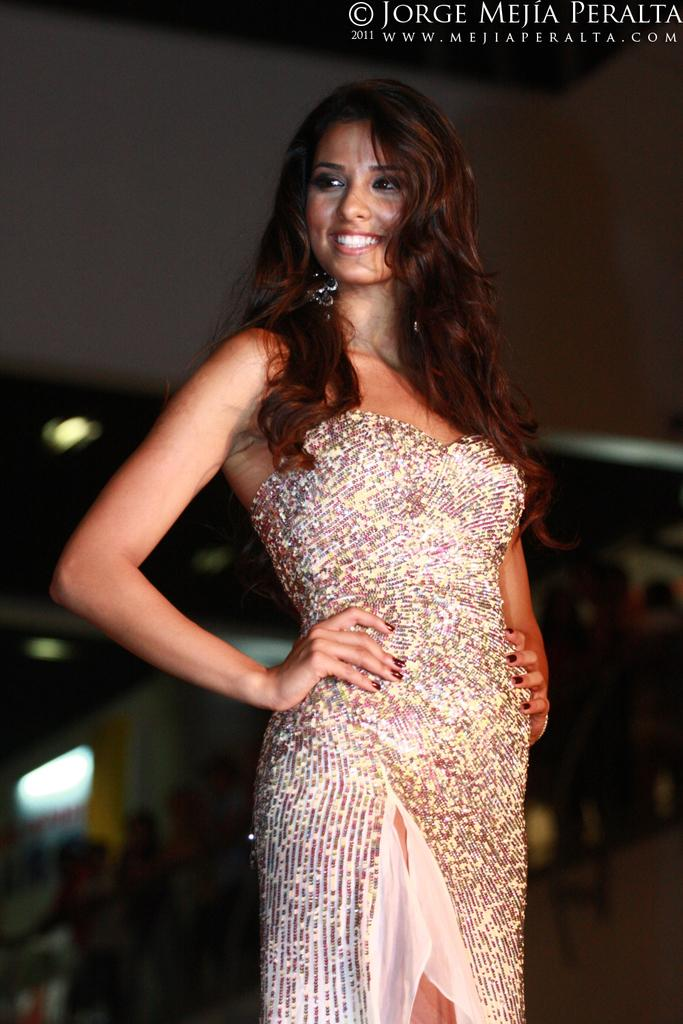What is the woman in the image doing? The woman is standing in the image and smiling. Can you describe the people in the background of the image? There is a group of people in the background of the image. What can be seen in the image that provides illumination? There are lights visible in the image. What is present in the top right corner of the image? There is text in the top right corner of the image. What type of waves can be seen crashing against the shore in the image? There are no waves or shore visible in the image; it features a woman standing with a group of people in the background. 